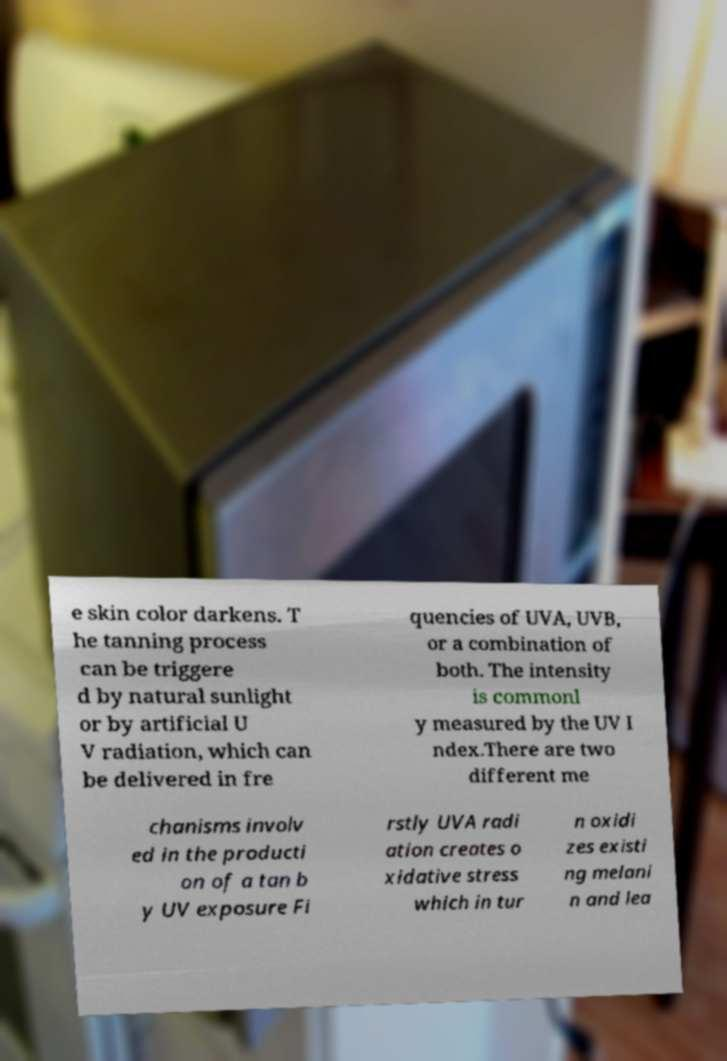Can you read and provide the text displayed in the image?This photo seems to have some interesting text. Can you extract and type it out for me? e skin color darkens. T he tanning process can be triggere d by natural sunlight or by artificial U V radiation, which can be delivered in fre quencies of UVA, UVB, or a combination of both. The intensity is commonl y measured by the UV I ndex.There are two different me chanisms involv ed in the producti on of a tan b y UV exposure Fi rstly UVA radi ation creates o xidative stress which in tur n oxidi zes existi ng melani n and lea 